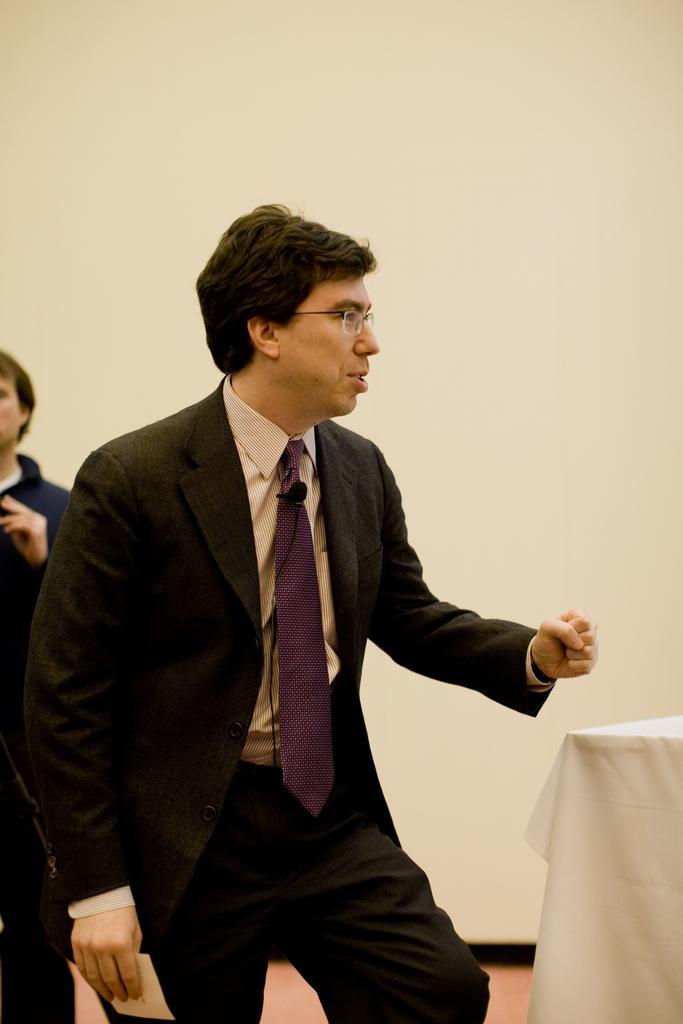Could you give a brief overview of what you see in this image? In this image we can see two persons standing, among them, one person is wearing spectacles and holding a piece of paper, there is a table covered with the white color cloth and in the background we can see the wall. 